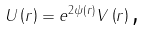<formula> <loc_0><loc_0><loc_500><loc_500>U \left ( r \right ) = e ^ { 2 \psi \left ( r \right ) } V \left ( r \right ) \text {,}</formula> 